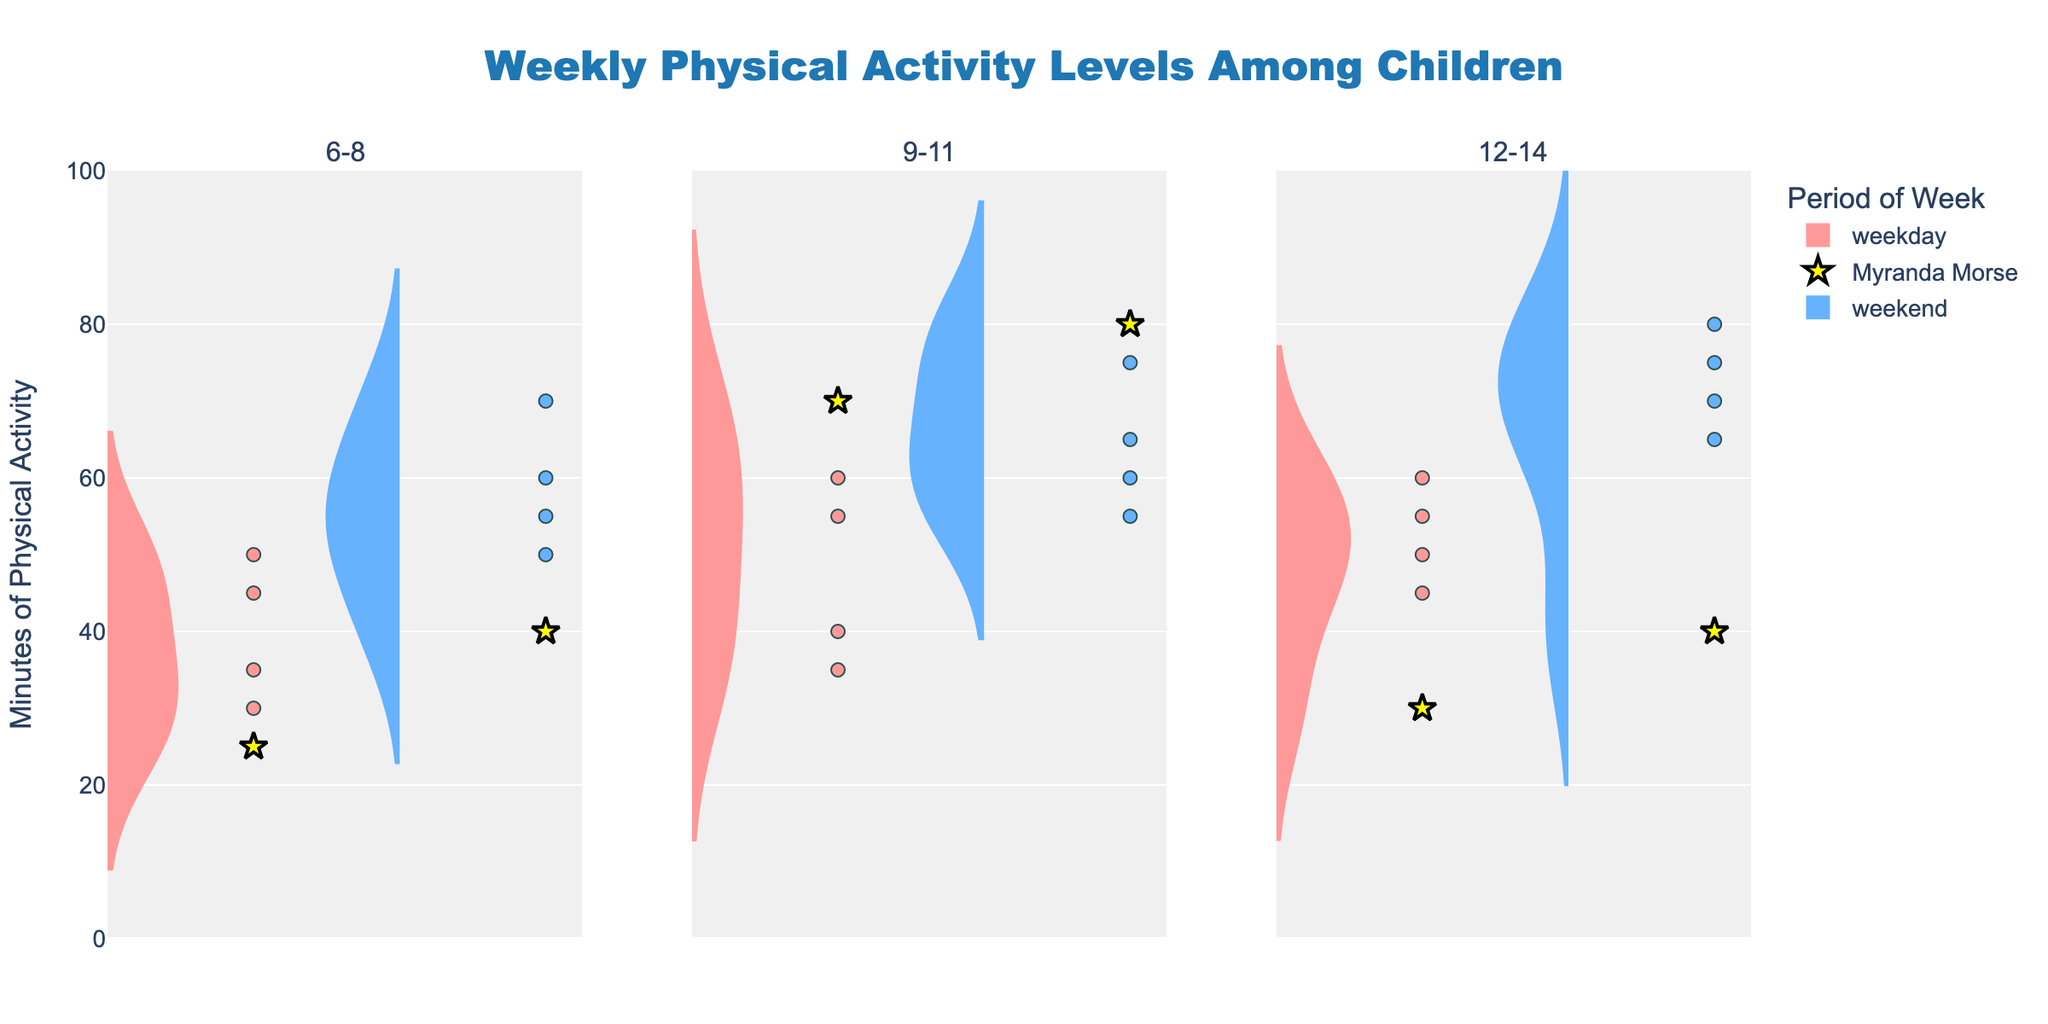What is the title of the figure? The title is displayed at the top of the figure in large, bold text. It reads "Weekly Physical Activity Levels Among Children."
Answer: Weekly Physical Activity Levels Among Children How many age groups are depicted in the figure? The figure has three columns, each associated with a different age group. The subplot titles indicate the age groups are "6-8," "9-11," and "12-14."
Answer: 3 Which period (weekday or weekend) shows higher physical activity levels for 6-8-year-olds? For the 6-8 age group (first column), the weekend violin chart extends higher in the y-axis compared to the weekday violin chart.
Answer: Weekend How many data points are there for Myranda Morse in total? Myranda Morse's data points are highlighted with yellow star markers. In each age group (three in total), she has one data point for weekdays and one for weekends, totaling six data points.
Answer: 6 What is the maximum value of minutes of physical activity recorded in the 9-11 age group on weekends? Looking at the second column for the 9-11 age group, the highest point on the y-axis within the weekend section indicates the maximum value, which is 80 minutes.
Answer: 80 minutes Compare the difference in Myranda Morse’s weekend physical activity levels between the 9-11 and 12-14 age groups. First, find Myranda Morse’s weekend physical activity for the 9-11 age group: 80 minutes. Then, find her activity level for the 12-14 age group: 40 minutes. The difference is 80 - 40 = 40 minutes.
Answer: 40 minutes In which age group does Myranda Morse have the highest weekday physical activity? Locate the yellow star markers for Myranda Morse in the weekday segments across all three columns. The highest star marker appears in the 9-11 age group, indicating 70 minutes.
Answer: 9-11 What is the range of physical activity minutes during weekdays for the 9-11 age group? Range is determined by subtracting the minimum value from the maximum value. For weekdays in the 9-11 group, the lowest y value is 35 and the highest is 70. Therefore, the range is 70 - 35 = 35 minutes.
Answer: 35 minutes Are there more data points for the period “weekend” or “weekday” in total? Count the data points in the violin plot sections for weekends and weekdays across all age groups. Both periods have the same number of data points because the dataset has an equal distribution of weekday and weekend entries for each child.
Answer: Equal 